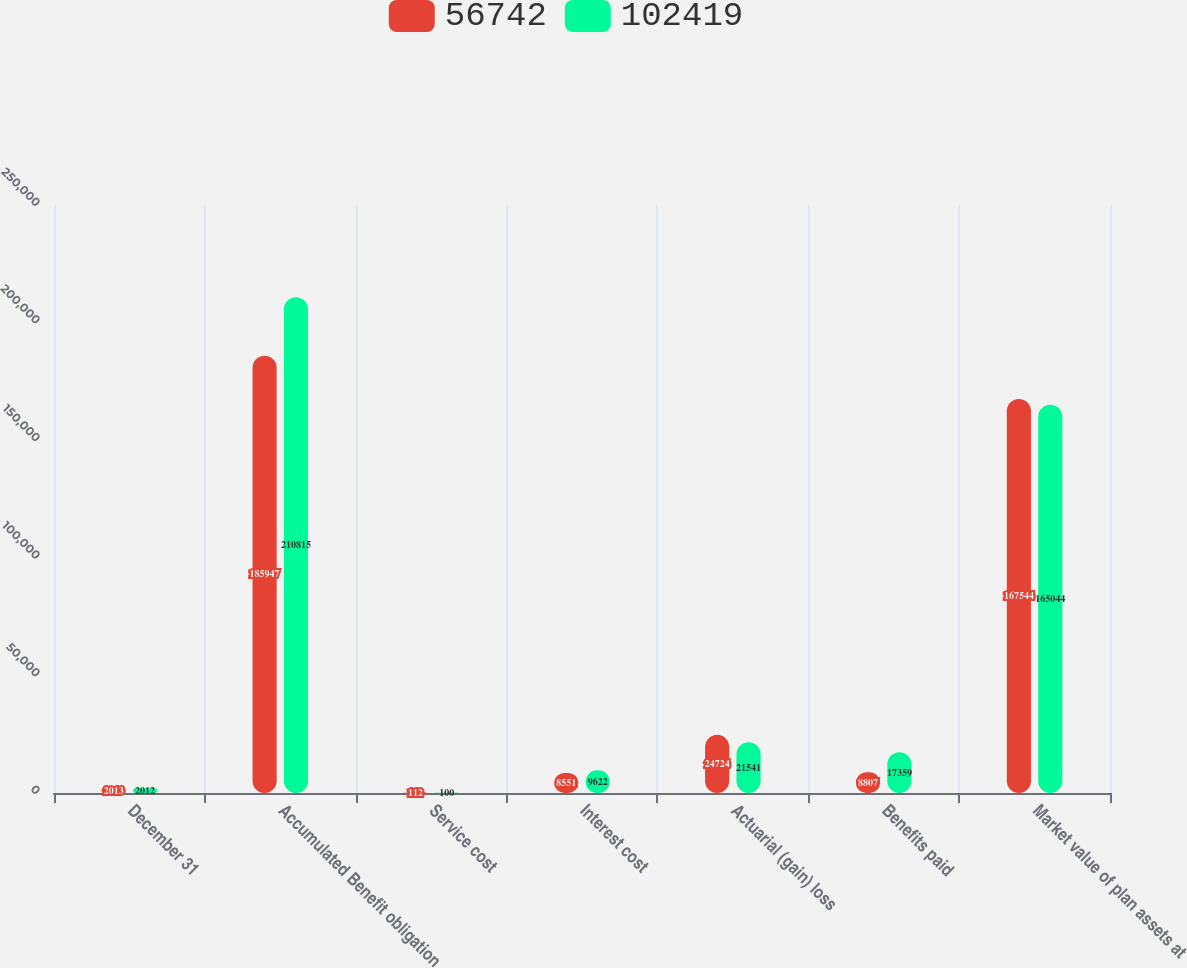<chart> <loc_0><loc_0><loc_500><loc_500><stacked_bar_chart><ecel><fcel>December 31<fcel>Accumulated Benefit obligation<fcel>Service cost<fcel>Interest cost<fcel>Actuarial (gain) loss<fcel>Benefits paid<fcel>Market value of plan assets at<nl><fcel>56742<fcel>2013<fcel>185947<fcel>112<fcel>8551<fcel>24724<fcel>8807<fcel>167544<nl><fcel>102419<fcel>2012<fcel>210815<fcel>100<fcel>9622<fcel>21541<fcel>17359<fcel>165044<nl></chart> 